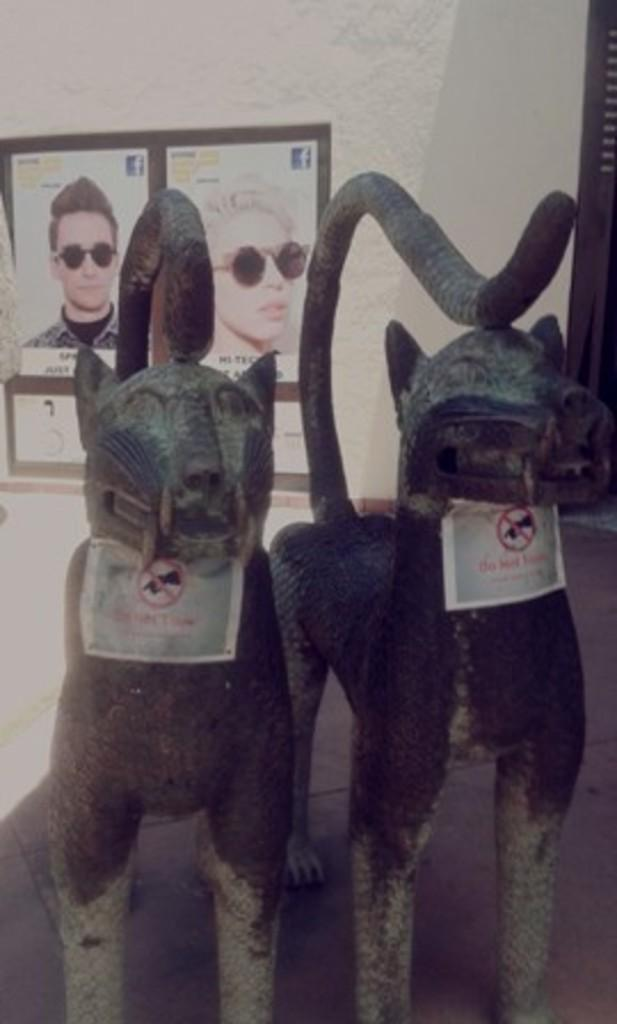What can be seen in the foreground of the image? There are two statues in the foreground of the image. What is on the statues? There are posters on the statues. What can be seen in the background of the image? There are posters on the wall in the background of the image. Can you see the finger painting on the canvas in the image? There is no canvas or finger painting present in the image. Are there any monkeys visible in the image? There are no monkeys visible in the image. 